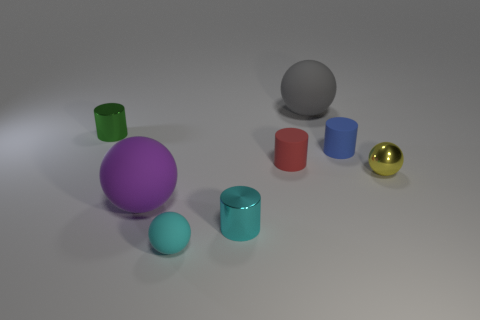Add 2 tiny matte cylinders. How many objects exist? 10 Add 5 small blue rubber things. How many small blue rubber things exist? 6 Subtract 0 red balls. How many objects are left? 8 Subtract all brown rubber objects. Subtract all large purple matte things. How many objects are left? 7 Add 3 large purple rubber things. How many large purple rubber things are left? 4 